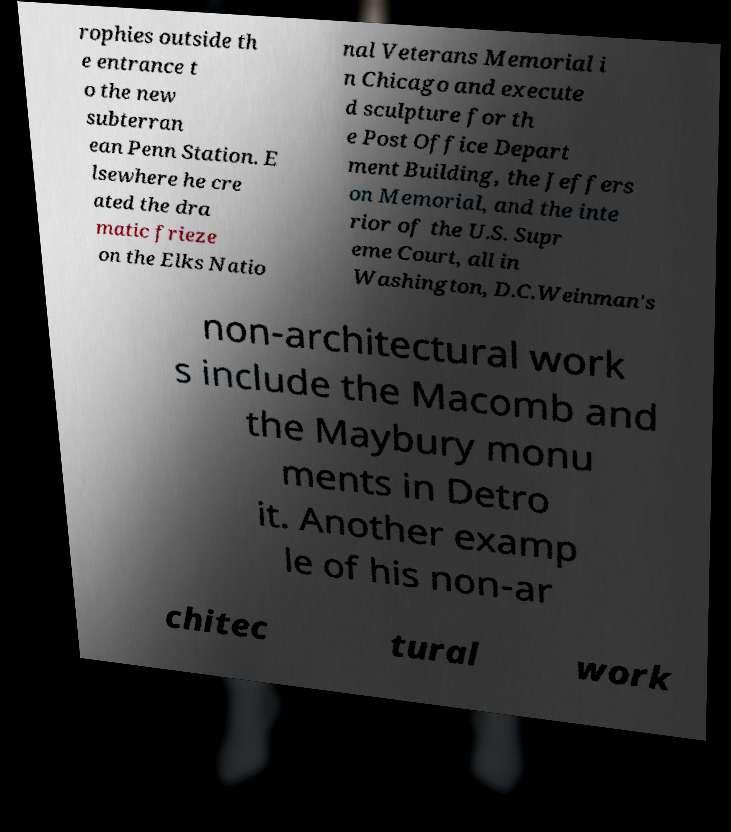Could you assist in decoding the text presented in this image and type it out clearly? rophies outside th e entrance t o the new subterran ean Penn Station. E lsewhere he cre ated the dra matic frieze on the Elks Natio nal Veterans Memorial i n Chicago and execute d sculpture for th e Post Office Depart ment Building, the Jeffers on Memorial, and the inte rior of the U.S. Supr eme Court, all in Washington, D.C.Weinman's non-architectural work s include the Macomb and the Maybury monu ments in Detro it. Another examp le of his non-ar chitec tural work 